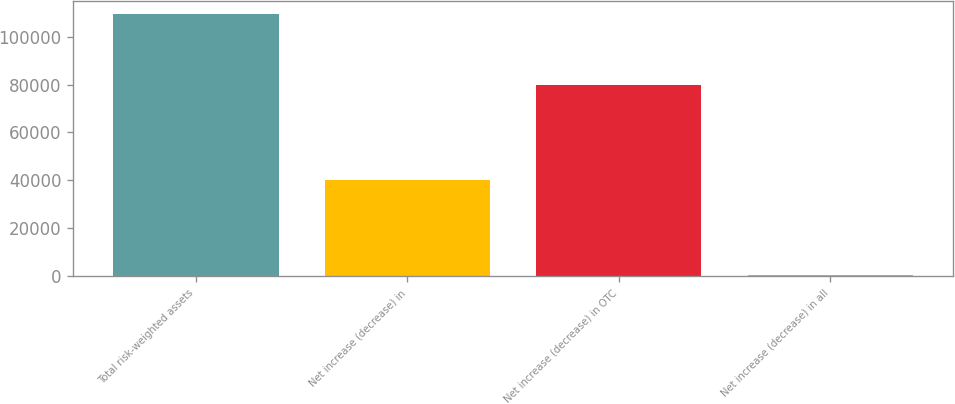Convert chart. <chart><loc_0><loc_0><loc_500><loc_500><bar_chart><fcel>Total risk-weighted assets<fcel>Net increase (decrease) in<fcel>Net increase (decrease) in OTC<fcel>Net increase (decrease) in all<nl><fcel>109462<fcel>40089<fcel>79731<fcel>447<nl></chart> 